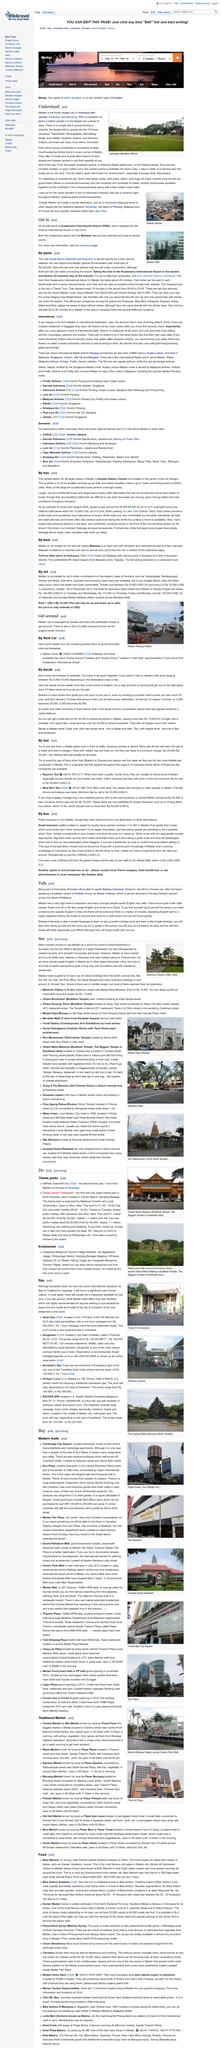Mention a couple of crucial points in this snapshot. The food in Medan is diverse due to the fact that the city is inhabited by many ethnic groups, each of which has its own unique cuisine. This diversity is a testament to the rich cultural heritage of the city and its inhabitants. The city of Medan has a population of approximately 2 million people, making it the largest city in Sumatra, Indonesia. Food is available in Medan for 24 hours a day, 7 days a week. 